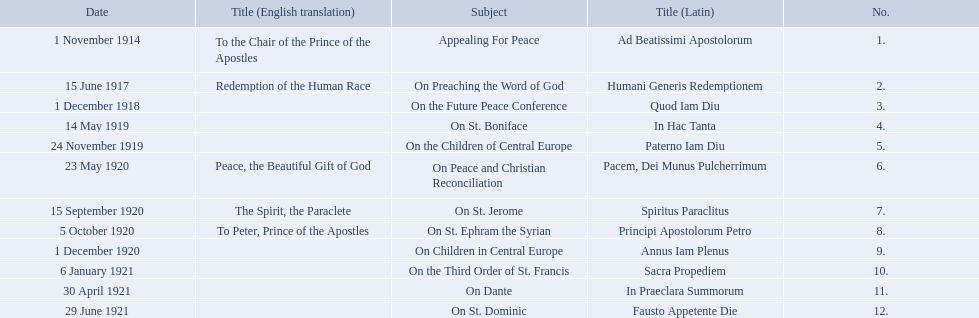What is the dates of the list of encyclicals of pope benedict xv? 1 November 1914, 15 June 1917, 1 December 1918, 14 May 1919, 24 November 1919, 23 May 1920, 15 September 1920, 5 October 1920, 1 December 1920, 6 January 1921, 30 April 1921, 29 June 1921. Of these dates, which subject was on 23 may 1920? On Peace and Christian Reconciliation. 